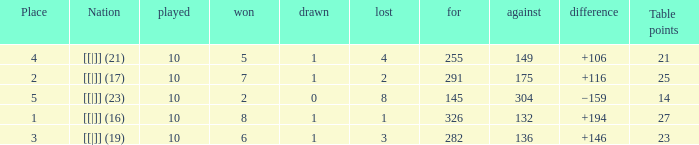 How many table points are listed for the deficit is +194?  1.0. 